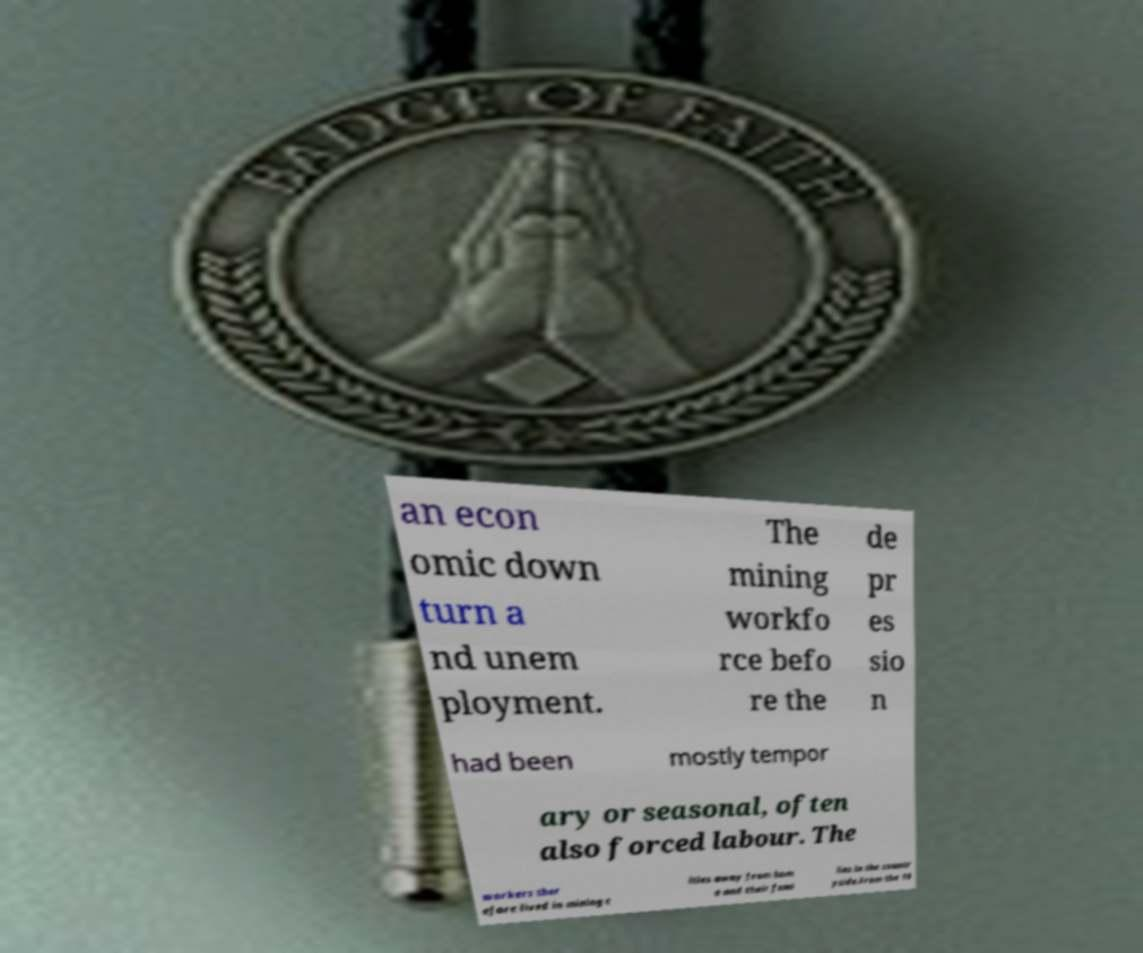I need the written content from this picture converted into text. Can you do that? an econ omic down turn a nd unem ployment. The mining workfo rce befo re the de pr es sio n had been mostly tempor ary or seasonal, often also forced labour. The workers ther efore lived in mining c ities away from hom e and their fami lies in the countr yside.From the 19 